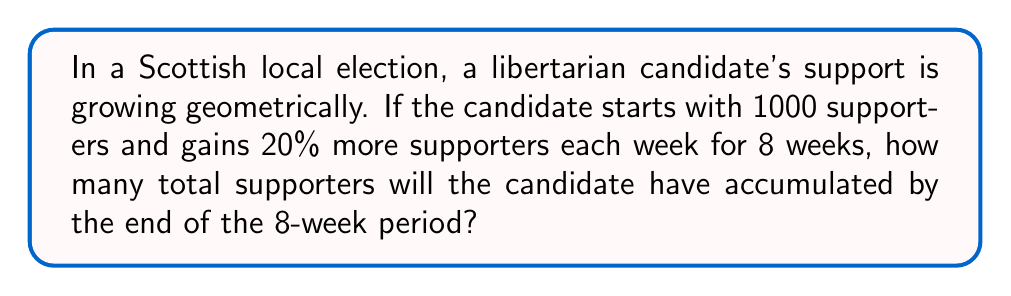Solve this math problem. Let's approach this step-by-step using a geometric series:

1) Initial term (a): 1000 supporters
2) Common ratio (r): 1.20 (20% increase = 1 + 0.20)
3) Number of terms (n): 9 (initial supporters plus 8 weeks of growth)

The formula for the sum of a geometric series is:

$$ S_n = a\frac{1-r^n}{1-r} $$

Where:
$S_n$ is the sum of the series
$a$ is the first term
$r$ is the common ratio
$n$ is the number of terms

Substituting our values:

$$ S_9 = 1000\frac{1-1.20^9}{1-1.20} $$

$$ S_9 = 1000\frac{1-5.159780352}{-0.20} $$

$$ S_9 = 1000\frac{-4.159780352}{-0.20} $$

$$ S_9 = 1000 \times 20.79890176 $$

$$ S_9 = 20798.90176 $$

Rounding to the nearest whole number (as we can't have fractional supporters):

$$ S_9 \approx 20799 $$
Answer: 20799 supporters 